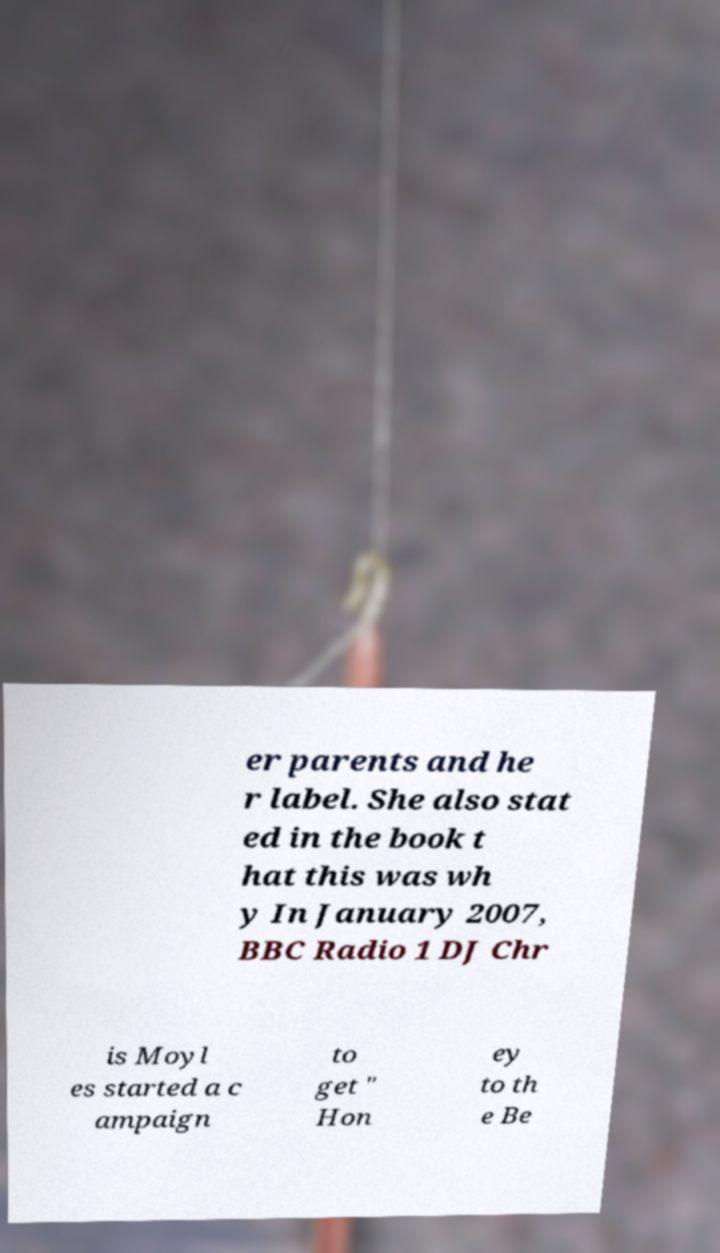What messages or text are displayed in this image? I need them in a readable, typed format. er parents and he r label. She also stat ed in the book t hat this was wh y In January 2007, BBC Radio 1 DJ Chr is Moyl es started a c ampaign to get " Hon ey to th e Be 